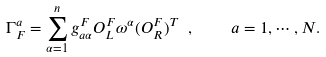Convert formula to latex. <formula><loc_0><loc_0><loc_500><loc_500>\Gamma ^ { a } _ { F } = \sum _ { \alpha = 1 } ^ { n } g _ { a \alpha } ^ { F } O _ { L } ^ { F } \omega ^ { \alpha } ( O _ { R } ^ { F } ) ^ { T } \ , \quad a = 1 , \cdots , N .</formula> 